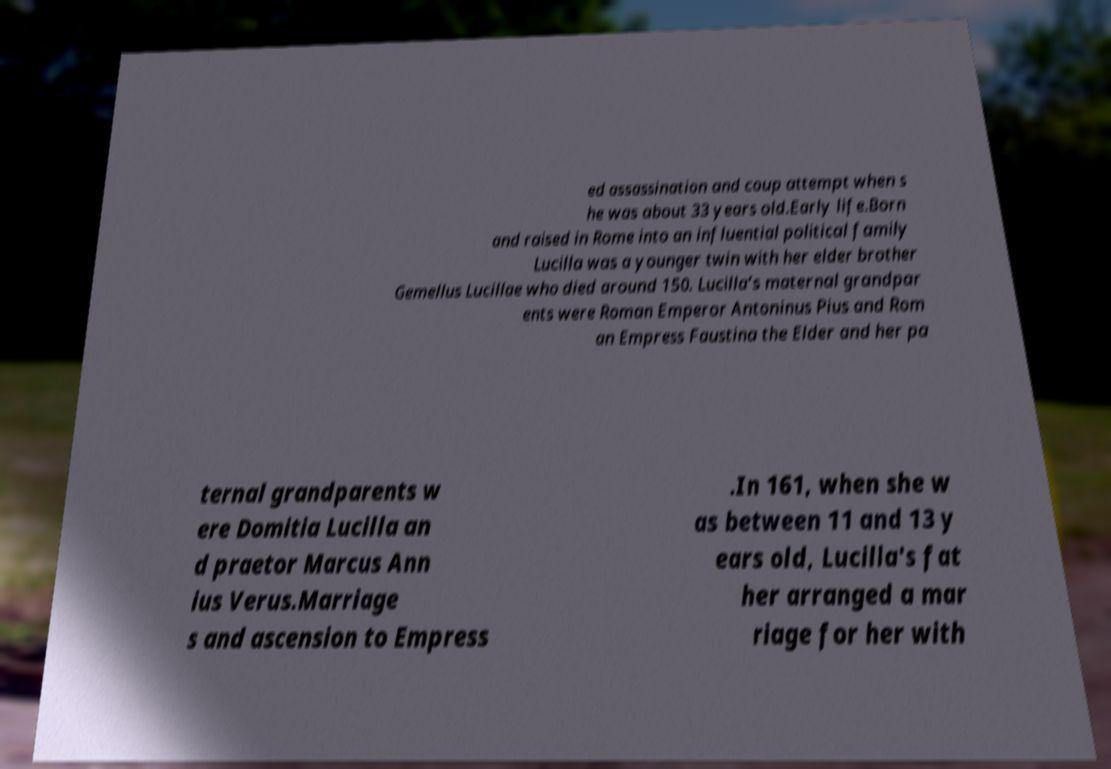Please identify and transcribe the text found in this image. ed assassination and coup attempt when s he was about 33 years old.Early life.Born and raised in Rome into an influential political family Lucilla was a younger twin with her elder brother Gemellus Lucillae who died around 150. Lucilla’s maternal grandpar ents were Roman Emperor Antoninus Pius and Rom an Empress Faustina the Elder and her pa ternal grandparents w ere Domitia Lucilla an d praetor Marcus Ann ius Verus.Marriage s and ascension to Empress .In 161, when she w as between 11 and 13 y ears old, Lucilla's fat her arranged a mar riage for her with 